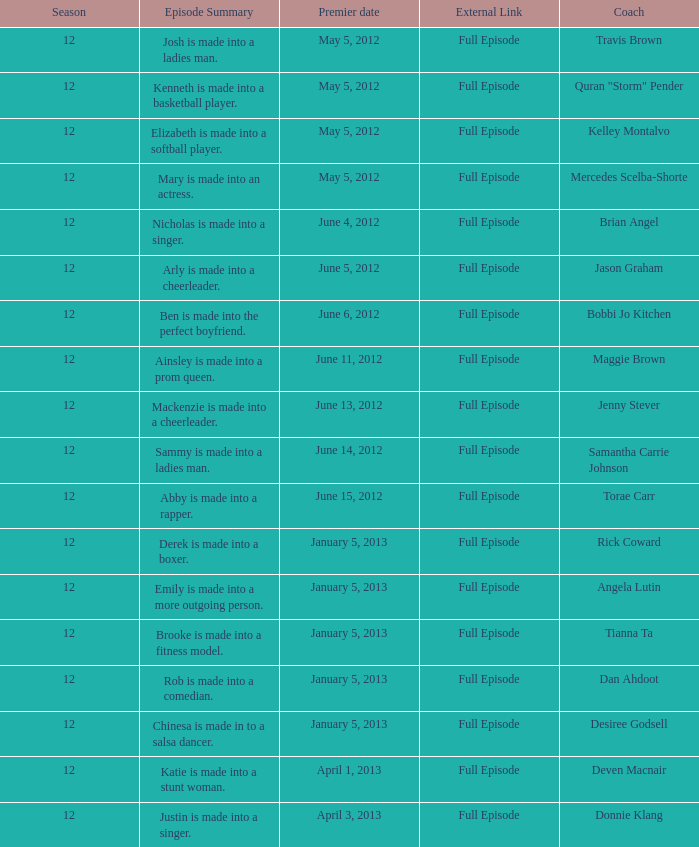Give me the full table as a dictionary. {'header': ['Season', 'Episode Summary', 'Premier date', 'External Link', 'Coach'], 'rows': [['12', 'Josh is made into a ladies man.', 'May 5, 2012', 'Full Episode', 'Travis Brown'], ['12', 'Kenneth is made into a basketball player.', 'May 5, 2012', 'Full Episode', 'Quran "Storm" Pender'], ['12', 'Elizabeth is made into a softball player.', 'May 5, 2012', 'Full Episode', 'Kelley Montalvo'], ['12', 'Mary is made into an actress.', 'May 5, 2012', 'Full Episode', 'Mercedes Scelba-Shorte'], ['12', 'Nicholas is made into a singer.', 'June 4, 2012', 'Full Episode', 'Brian Angel'], ['12', 'Arly is made into a cheerleader.', 'June 5, 2012', 'Full Episode', 'Jason Graham'], ['12', 'Ben is made into the perfect boyfriend.', 'June 6, 2012', 'Full Episode', 'Bobbi Jo Kitchen'], ['12', 'Ainsley is made into a prom queen.', 'June 11, 2012', 'Full Episode', 'Maggie Brown'], ['12', 'Mackenzie is made into a cheerleader.', 'June 13, 2012', 'Full Episode', 'Jenny Stever'], ['12', 'Sammy is made into a ladies man.', 'June 14, 2012', 'Full Episode', 'Samantha Carrie Johnson'], ['12', 'Abby is made into a rapper.', 'June 15, 2012', 'Full Episode', 'Torae Carr'], ['12', 'Derek is made into a boxer.', 'January 5, 2013', 'Full Episode', 'Rick Coward'], ['12', 'Emily is made into a more outgoing person.', 'January 5, 2013', 'Full Episode', 'Angela Lutin'], ['12', 'Brooke is made into a fitness model.', 'January 5, 2013', 'Full Episode', 'Tianna Ta'], ['12', 'Rob is made into a comedian.', 'January 5, 2013', 'Full Episode', 'Dan Ahdoot'], ['12', 'Chinesa is made in to a salsa dancer.', 'January 5, 2013', 'Full Episode', 'Desiree Godsell'], ['12', 'Katie is made into a stunt woman.', 'April 1, 2013', 'Full Episode', 'Deven Macnair'], ['12', 'Justin is made into a singer.', 'April 3, 2013', 'Full Episode', 'Donnie Klang']]} What is the episode outline for travis brown? Josh is made into a ladies man. 